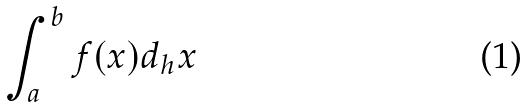Convert formula to latex. <formula><loc_0><loc_0><loc_500><loc_500>\int _ { a } ^ { b } f ( x ) d _ { h } x</formula> 